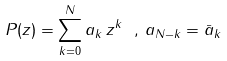<formula> <loc_0><loc_0><loc_500><loc_500>P ( z ) = \sum ^ { N } _ { k = 0 } a _ { k } \, z ^ { k } \ , \, a _ { N - k } = { \bar { a } } _ { k }</formula> 